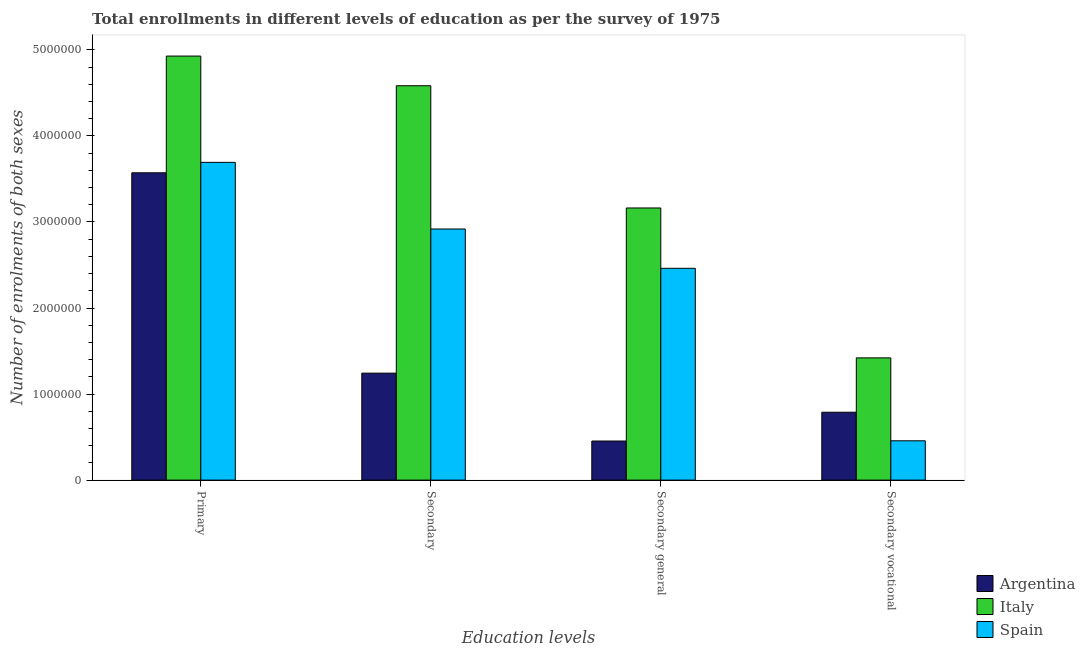Are the number of bars per tick equal to the number of legend labels?
Offer a terse response. Yes. What is the label of the 3rd group of bars from the left?
Your answer should be very brief. Secondary general. What is the number of enrolments in secondary vocational education in Spain?
Your answer should be very brief. 4.57e+05. Across all countries, what is the maximum number of enrolments in secondary education?
Make the answer very short. 4.58e+06. Across all countries, what is the minimum number of enrolments in secondary general education?
Your response must be concise. 4.54e+05. What is the total number of enrolments in primary education in the graph?
Your answer should be very brief. 1.22e+07. What is the difference between the number of enrolments in secondary education in Italy and that in Spain?
Your answer should be compact. 1.66e+06. What is the difference between the number of enrolments in primary education in Italy and the number of enrolments in secondary vocational education in Argentina?
Offer a terse response. 4.14e+06. What is the average number of enrolments in primary education per country?
Keep it short and to the point. 4.06e+06. What is the difference between the number of enrolments in secondary vocational education and number of enrolments in secondary education in Italy?
Your answer should be compact. -3.16e+06. What is the ratio of the number of enrolments in secondary vocational education in Spain to that in Italy?
Offer a very short reply. 0.32. What is the difference between the highest and the second highest number of enrolments in primary education?
Make the answer very short. 1.23e+06. What is the difference between the highest and the lowest number of enrolments in primary education?
Offer a very short reply. 1.36e+06. How many bars are there?
Give a very brief answer. 12. Are all the bars in the graph horizontal?
Your response must be concise. No. How many countries are there in the graph?
Make the answer very short. 3. What is the difference between two consecutive major ticks on the Y-axis?
Your response must be concise. 1.00e+06. Where does the legend appear in the graph?
Make the answer very short. Bottom right. How many legend labels are there?
Offer a terse response. 3. How are the legend labels stacked?
Provide a succinct answer. Vertical. What is the title of the graph?
Your response must be concise. Total enrollments in different levels of education as per the survey of 1975. Does "American Samoa" appear as one of the legend labels in the graph?
Keep it short and to the point. No. What is the label or title of the X-axis?
Your answer should be very brief. Education levels. What is the label or title of the Y-axis?
Ensure brevity in your answer.  Number of enrolments of both sexes. What is the Number of enrolments of both sexes in Argentina in Primary?
Give a very brief answer. 3.57e+06. What is the Number of enrolments of both sexes in Italy in Primary?
Make the answer very short. 4.93e+06. What is the Number of enrolments of both sexes in Spain in Primary?
Give a very brief answer. 3.69e+06. What is the Number of enrolments of both sexes in Argentina in Secondary?
Offer a terse response. 1.24e+06. What is the Number of enrolments of both sexes in Italy in Secondary?
Offer a terse response. 4.58e+06. What is the Number of enrolments of both sexes of Spain in Secondary?
Give a very brief answer. 2.92e+06. What is the Number of enrolments of both sexes in Argentina in Secondary general?
Provide a short and direct response. 4.54e+05. What is the Number of enrolments of both sexes in Italy in Secondary general?
Provide a succinct answer. 3.16e+06. What is the Number of enrolments of both sexes of Spain in Secondary general?
Your answer should be compact. 2.46e+06. What is the Number of enrolments of both sexes in Argentina in Secondary vocational?
Your response must be concise. 7.89e+05. What is the Number of enrolments of both sexes in Italy in Secondary vocational?
Provide a succinct answer. 1.42e+06. What is the Number of enrolments of both sexes in Spain in Secondary vocational?
Make the answer very short. 4.57e+05. Across all Education levels, what is the maximum Number of enrolments of both sexes of Argentina?
Your answer should be compact. 3.57e+06. Across all Education levels, what is the maximum Number of enrolments of both sexes in Italy?
Provide a short and direct response. 4.93e+06. Across all Education levels, what is the maximum Number of enrolments of both sexes of Spain?
Keep it short and to the point. 3.69e+06. Across all Education levels, what is the minimum Number of enrolments of both sexes in Argentina?
Offer a terse response. 4.54e+05. Across all Education levels, what is the minimum Number of enrolments of both sexes in Italy?
Make the answer very short. 1.42e+06. Across all Education levels, what is the minimum Number of enrolments of both sexes of Spain?
Give a very brief answer. 4.57e+05. What is the total Number of enrolments of both sexes of Argentina in the graph?
Your response must be concise. 6.06e+06. What is the total Number of enrolments of both sexes of Italy in the graph?
Give a very brief answer. 1.41e+07. What is the total Number of enrolments of both sexes of Spain in the graph?
Provide a short and direct response. 9.53e+06. What is the difference between the Number of enrolments of both sexes of Argentina in Primary and that in Secondary?
Ensure brevity in your answer.  2.33e+06. What is the difference between the Number of enrolments of both sexes of Italy in Primary and that in Secondary?
Your response must be concise. 3.45e+05. What is the difference between the Number of enrolments of both sexes of Spain in Primary and that in Secondary?
Keep it short and to the point. 7.74e+05. What is the difference between the Number of enrolments of both sexes of Argentina in Primary and that in Secondary general?
Your answer should be compact. 3.12e+06. What is the difference between the Number of enrolments of both sexes of Italy in Primary and that in Secondary general?
Offer a terse response. 1.77e+06. What is the difference between the Number of enrolments of both sexes in Spain in Primary and that in Secondary general?
Offer a terse response. 1.23e+06. What is the difference between the Number of enrolments of both sexes of Argentina in Primary and that in Secondary vocational?
Make the answer very short. 2.78e+06. What is the difference between the Number of enrolments of both sexes in Italy in Primary and that in Secondary vocational?
Your answer should be compact. 3.51e+06. What is the difference between the Number of enrolments of both sexes of Spain in Primary and that in Secondary vocational?
Your response must be concise. 3.24e+06. What is the difference between the Number of enrolments of both sexes of Argentina in Secondary and that in Secondary general?
Your answer should be compact. 7.89e+05. What is the difference between the Number of enrolments of both sexes in Italy in Secondary and that in Secondary general?
Keep it short and to the point. 1.42e+06. What is the difference between the Number of enrolments of both sexes of Spain in Secondary and that in Secondary general?
Provide a short and direct response. 4.57e+05. What is the difference between the Number of enrolments of both sexes of Argentina in Secondary and that in Secondary vocational?
Provide a succinct answer. 4.54e+05. What is the difference between the Number of enrolments of both sexes of Italy in Secondary and that in Secondary vocational?
Ensure brevity in your answer.  3.16e+06. What is the difference between the Number of enrolments of both sexes in Spain in Secondary and that in Secondary vocational?
Keep it short and to the point. 2.46e+06. What is the difference between the Number of enrolments of both sexes in Argentina in Secondary general and that in Secondary vocational?
Your answer should be compact. -3.35e+05. What is the difference between the Number of enrolments of both sexes of Italy in Secondary general and that in Secondary vocational?
Offer a very short reply. 1.74e+06. What is the difference between the Number of enrolments of both sexes of Spain in Secondary general and that in Secondary vocational?
Your answer should be very brief. 2.00e+06. What is the difference between the Number of enrolments of both sexes of Argentina in Primary and the Number of enrolments of both sexes of Italy in Secondary?
Your answer should be very brief. -1.01e+06. What is the difference between the Number of enrolments of both sexes in Argentina in Primary and the Number of enrolments of both sexes in Spain in Secondary?
Provide a succinct answer. 6.53e+05. What is the difference between the Number of enrolments of both sexes of Italy in Primary and the Number of enrolments of both sexes of Spain in Secondary?
Give a very brief answer. 2.01e+06. What is the difference between the Number of enrolments of both sexes of Argentina in Primary and the Number of enrolments of both sexes of Italy in Secondary general?
Your answer should be very brief. 4.09e+05. What is the difference between the Number of enrolments of both sexes of Argentina in Primary and the Number of enrolments of both sexes of Spain in Secondary general?
Make the answer very short. 1.11e+06. What is the difference between the Number of enrolments of both sexes of Italy in Primary and the Number of enrolments of both sexes of Spain in Secondary general?
Provide a short and direct response. 2.47e+06. What is the difference between the Number of enrolments of both sexes in Argentina in Primary and the Number of enrolments of both sexes in Italy in Secondary vocational?
Give a very brief answer. 2.15e+06. What is the difference between the Number of enrolments of both sexes of Argentina in Primary and the Number of enrolments of both sexes of Spain in Secondary vocational?
Ensure brevity in your answer.  3.11e+06. What is the difference between the Number of enrolments of both sexes of Italy in Primary and the Number of enrolments of both sexes of Spain in Secondary vocational?
Ensure brevity in your answer.  4.47e+06. What is the difference between the Number of enrolments of both sexes in Argentina in Secondary and the Number of enrolments of both sexes in Italy in Secondary general?
Your response must be concise. -1.92e+06. What is the difference between the Number of enrolments of both sexes of Argentina in Secondary and the Number of enrolments of both sexes of Spain in Secondary general?
Your response must be concise. -1.22e+06. What is the difference between the Number of enrolments of both sexes in Italy in Secondary and the Number of enrolments of both sexes in Spain in Secondary general?
Ensure brevity in your answer.  2.12e+06. What is the difference between the Number of enrolments of both sexes in Argentina in Secondary and the Number of enrolments of both sexes in Italy in Secondary vocational?
Make the answer very short. -1.77e+05. What is the difference between the Number of enrolments of both sexes in Argentina in Secondary and the Number of enrolments of both sexes in Spain in Secondary vocational?
Provide a succinct answer. 7.86e+05. What is the difference between the Number of enrolments of both sexes in Italy in Secondary and the Number of enrolments of both sexes in Spain in Secondary vocational?
Offer a very short reply. 4.13e+06. What is the difference between the Number of enrolments of both sexes of Argentina in Secondary general and the Number of enrolments of both sexes of Italy in Secondary vocational?
Provide a succinct answer. -9.66e+05. What is the difference between the Number of enrolments of both sexes of Argentina in Secondary general and the Number of enrolments of both sexes of Spain in Secondary vocational?
Provide a short and direct response. -2622. What is the difference between the Number of enrolments of both sexes of Italy in Secondary general and the Number of enrolments of both sexes of Spain in Secondary vocational?
Your response must be concise. 2.71e+06. What is the average Number of enrolments of both sexes of Argentina per Education levels?
Provide a short and direct response. 1.51e+06. What is the average Number of enrolments of both sexes of Italy per Education levels?
Provide a succinct answer. 3.52e+06. What is the average Number of enrolments of both sexes in Spain per Education levels?
Ensure brevity in your answer.  2.38e+06. What is the difference between the Number of enrolments of both sexes in Argentina and Number of enrolments of both sexes in Italy in Primary?
Offer a very short reply. -1.36e+06. What is the difference between the Number of enrolments of both sexes of Argentina and Number of enrolments of both sexes of Spain in Primary?
Provide a succinct answer. -1.21e+05. What is the difference between the Number of enrolments of both sexes of Italy and Number of enrolments of both sexes of Spain in Primary?
Offer a very short reply. 1.23e+06. What is the difference between the Number of enrolments of both sexes in Argentina and Number of enrolments of both sexes in Italy in Secondary?
Provide a succinct answer. -3.34e+06. What is the difference between the Number of enrolments of both sexes of Argentina and Number of enrolments of both sexes of Spain in Secondary?
Keep it short and to the point. -1.68e+06. What is the difference between the Number of enrolments of both sexes in Italy and Number of enrolments of both sexes in Spain in Secondary?
Your response must be concise. 1.66e+06. What is the difference between the Number of enrolments of both sexes in Argentina and Number of enrolments of both sexes in Italy in Secondary general?
Offer a terse response. -2.71e+06. What is the difference between the Number of enrolments of both sexes in Argentina and Number of enrolments of both sexes in Spain in Secondary general?
Keep it short and to the point. -2.01e+06. What is the difference between the Number of enrolments of both sexes in Italy and Number of enrolments of both sexes in Spain in Secondary general?
Make the answer very short. 7.01e+05. What is the difference between the Number of enrolments of both sexes in Argentina and Number of enrolments of both sexes in Italy in Secondary vocational?
Your answer should be compact. -6.32e+05. What is the difference between the Number of enrolments of both sexes in Argentina and Number of enrolments of both sexes in Spain in Secondary vocational?
Your answer should be very brief. 3.32e+05. What is the difference between the Number of enrolments of both sexes in Italy and Number of enrolments of both sexes in Spain in Secondary vocational?
Your response must be concise. 9.64e+05. What is the ratio of the Number of enrolments of both sexes in Argentina in Primary to that in Secondary?
Offer a very short reply. 2.87. What is the ratio of the Number of enrolments of both sexes in Italy in Primary to that in Secondary?
Offer a terse response. 1.08. What is the ratio of the Number of enrolments of both sexes of Spain in Primary to that in Secondary?
Your response must be concise. 1.27. What is the ratio of the Number of enrolments of both sexes of Argentina in Primary to that in Secondary general?
Keep it short and to the point. 7.86. What is the ratio of the Number of enrolments of both sexes of Italy in Primary to that in Secondary general?
Offer a very short reply. 1.56. What is the ratio of the Number of enrolments of both sexes in Spain in Primary to that in Secondary general?
Your response must be concise. 1.5. What is the ratio of the Number of enrolments of both sexes of Argentina in Primary to that in Secondary vocational?
Your answer should be very brief. 4.53. What is the ratio of the Number of enrolments of both sexes in Italy in Primary to that in Secondary vocational?
Your answer should be very brief. 3.47. What is the ratio of the Number of enrolments of both sexes in Spain in Primary to that in Secondary vocational?
Provide a short and direct response. 8.08. What is the ratio of the Number of enrolments of both sexes of Argentina in Secondary to that in Secondary general?
Your response must be concise. 2.74. What is the ratio of the Number of enrolments of both sexes of Italy in Secondary to that in Secondary general?
Provide a succinct answer. 1.45. What is the ratio of the Number of enrolments of both sexes in Spain in Secondary to that in Secondary general?
Your response must be concise. 1.19. What is the ratio of the Number of enrolments of both sexes of Argentina in Secondary to that in Secondary vocational?
Your response must be concise. 1.58. What is the ratio of the Number of enrolments of both sexes of Italy in Secondary to that in Secondary vocational?
Ensure brevity in your answer.  3.23. What is the ratio of the Number of enrolments of both sexes of Spain in Secondary to that in Secondary vocational?
Ensure brevity in your answer.  6.39. What is the ratio of the Number of enrolments of both sexes in Argentina in Secondary general to that in Secondary vocational?
Make the answer very short. 0.58. What is the ratio of the Number of enrolments of both sexes in Italy in Secondary general to that in Secondary vocational?
Provide a short and direct response. 2.23. What is the ratio of the Number of enrolments of both sexes of Spain in Secondary general to that in Secondary vocational?
Your answer should be very brief. 5.39. What is the difference between the highest and the second highest Number of enrolments of both sexes of Argentina?
Make the answer very short. 2.33e+06. What is the difference between the highest and the second highest Number of enrolments of both sexes of Italy?
Give a very brief answer. 3.45e+05. What is the difference between the highest and the second highest Number of enrolments of both sexes in Spain?
Offer a very short reply. 7.74e+05. What is the difference between the highest and the lowest Number of enrolments of both sexes of Argentina?
Give a very brief answer. 3.12e+06. What is the difference between the highest and the lowest Number of enrolments of both sexes of Italy?
Keep it short and to the point. 3.51e+06. What is the difference between the highest and the lowest Number of enrolments of both sexes in Spain?
Make the answer very short. 3.24e+06. 